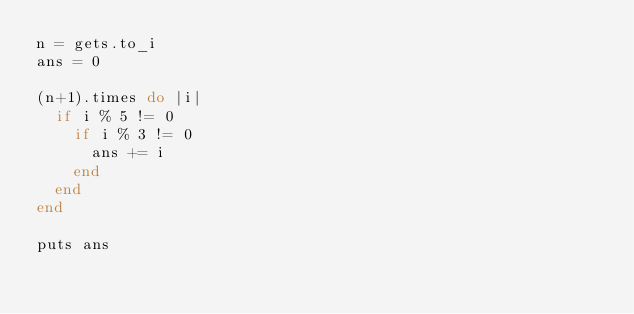Convert code to text. <code><loc_0><loc_0><loc_500><loc_500><_Ruby_>n = gets.to_i
ans = 0

(n+1).times do |i|
  if i % 5 != 0
    if i % 3 != 0
      ans += i
    end
  end
end

puts ans</code> 